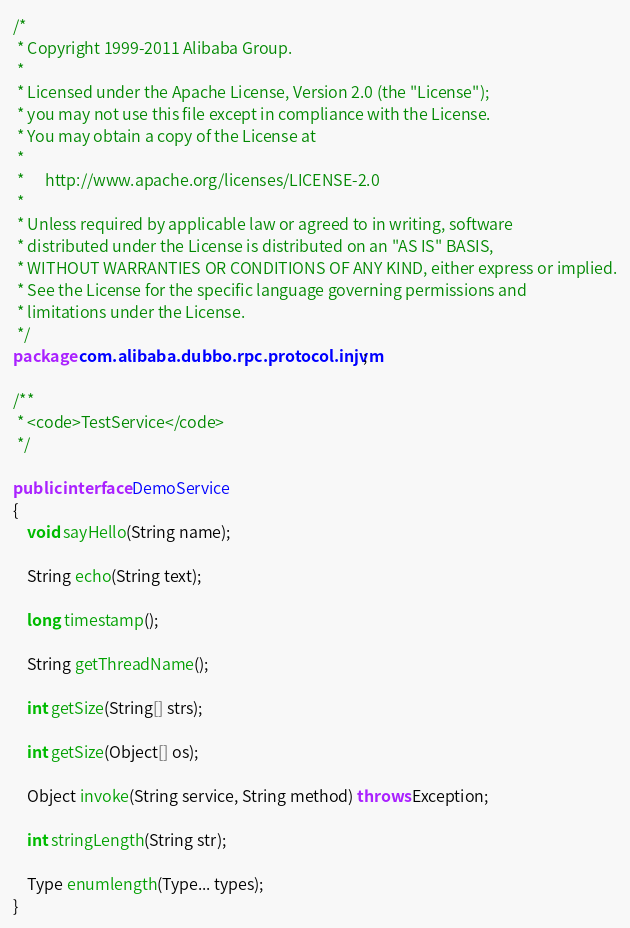Convert code to text. <code><loc_0><loc_0><loc_500><loc_500><_Java_>/*
 * Copyright 1999-2011 Alibaba Group.
 *  
 * Licensed under the Apache License, Version 2.0 (the "License");
 * you may not use this file except in compliance with the License.
 * You may obtain a copy of the License at
 *  
 *      http://www.apache.org/licenses/LICENSE-2.0
 *  
 * Unless required by applicable law or agreed to in writing, software
 * distributed under the License is distributed on an "AS IS" BASIS,
 * WITHOUT WARRANTIES OR CONDITIONS OF ANY KIND, either express or implied.
 * See the License for the specific language governing permissions and
 * limitations under the License.
 */
package com.alibaba.dubbo.rpc.protocol.injvm;

/**
 * <code>TestService</code>
 */

public interface DemoService
{
	void sayHello(String name);

	String echo(String text);

	long timestamp();

	String getThreadName();

	int getSize(String[] strs);

	int getSize(Object[] os);

	Object invoke(String service, String method) throws Exception;

	int stringLength(String str);

	Type enumlength(Type... types);
}</code> 